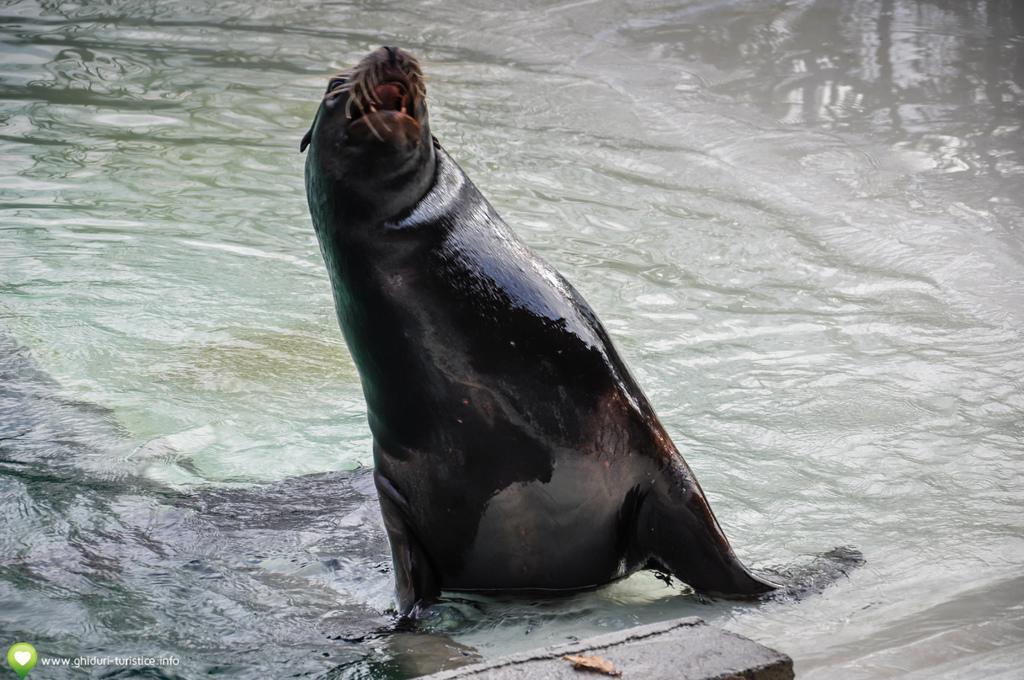In one or two sentences, can you explain what this image depicts? Here we can see an animal and this is water. 